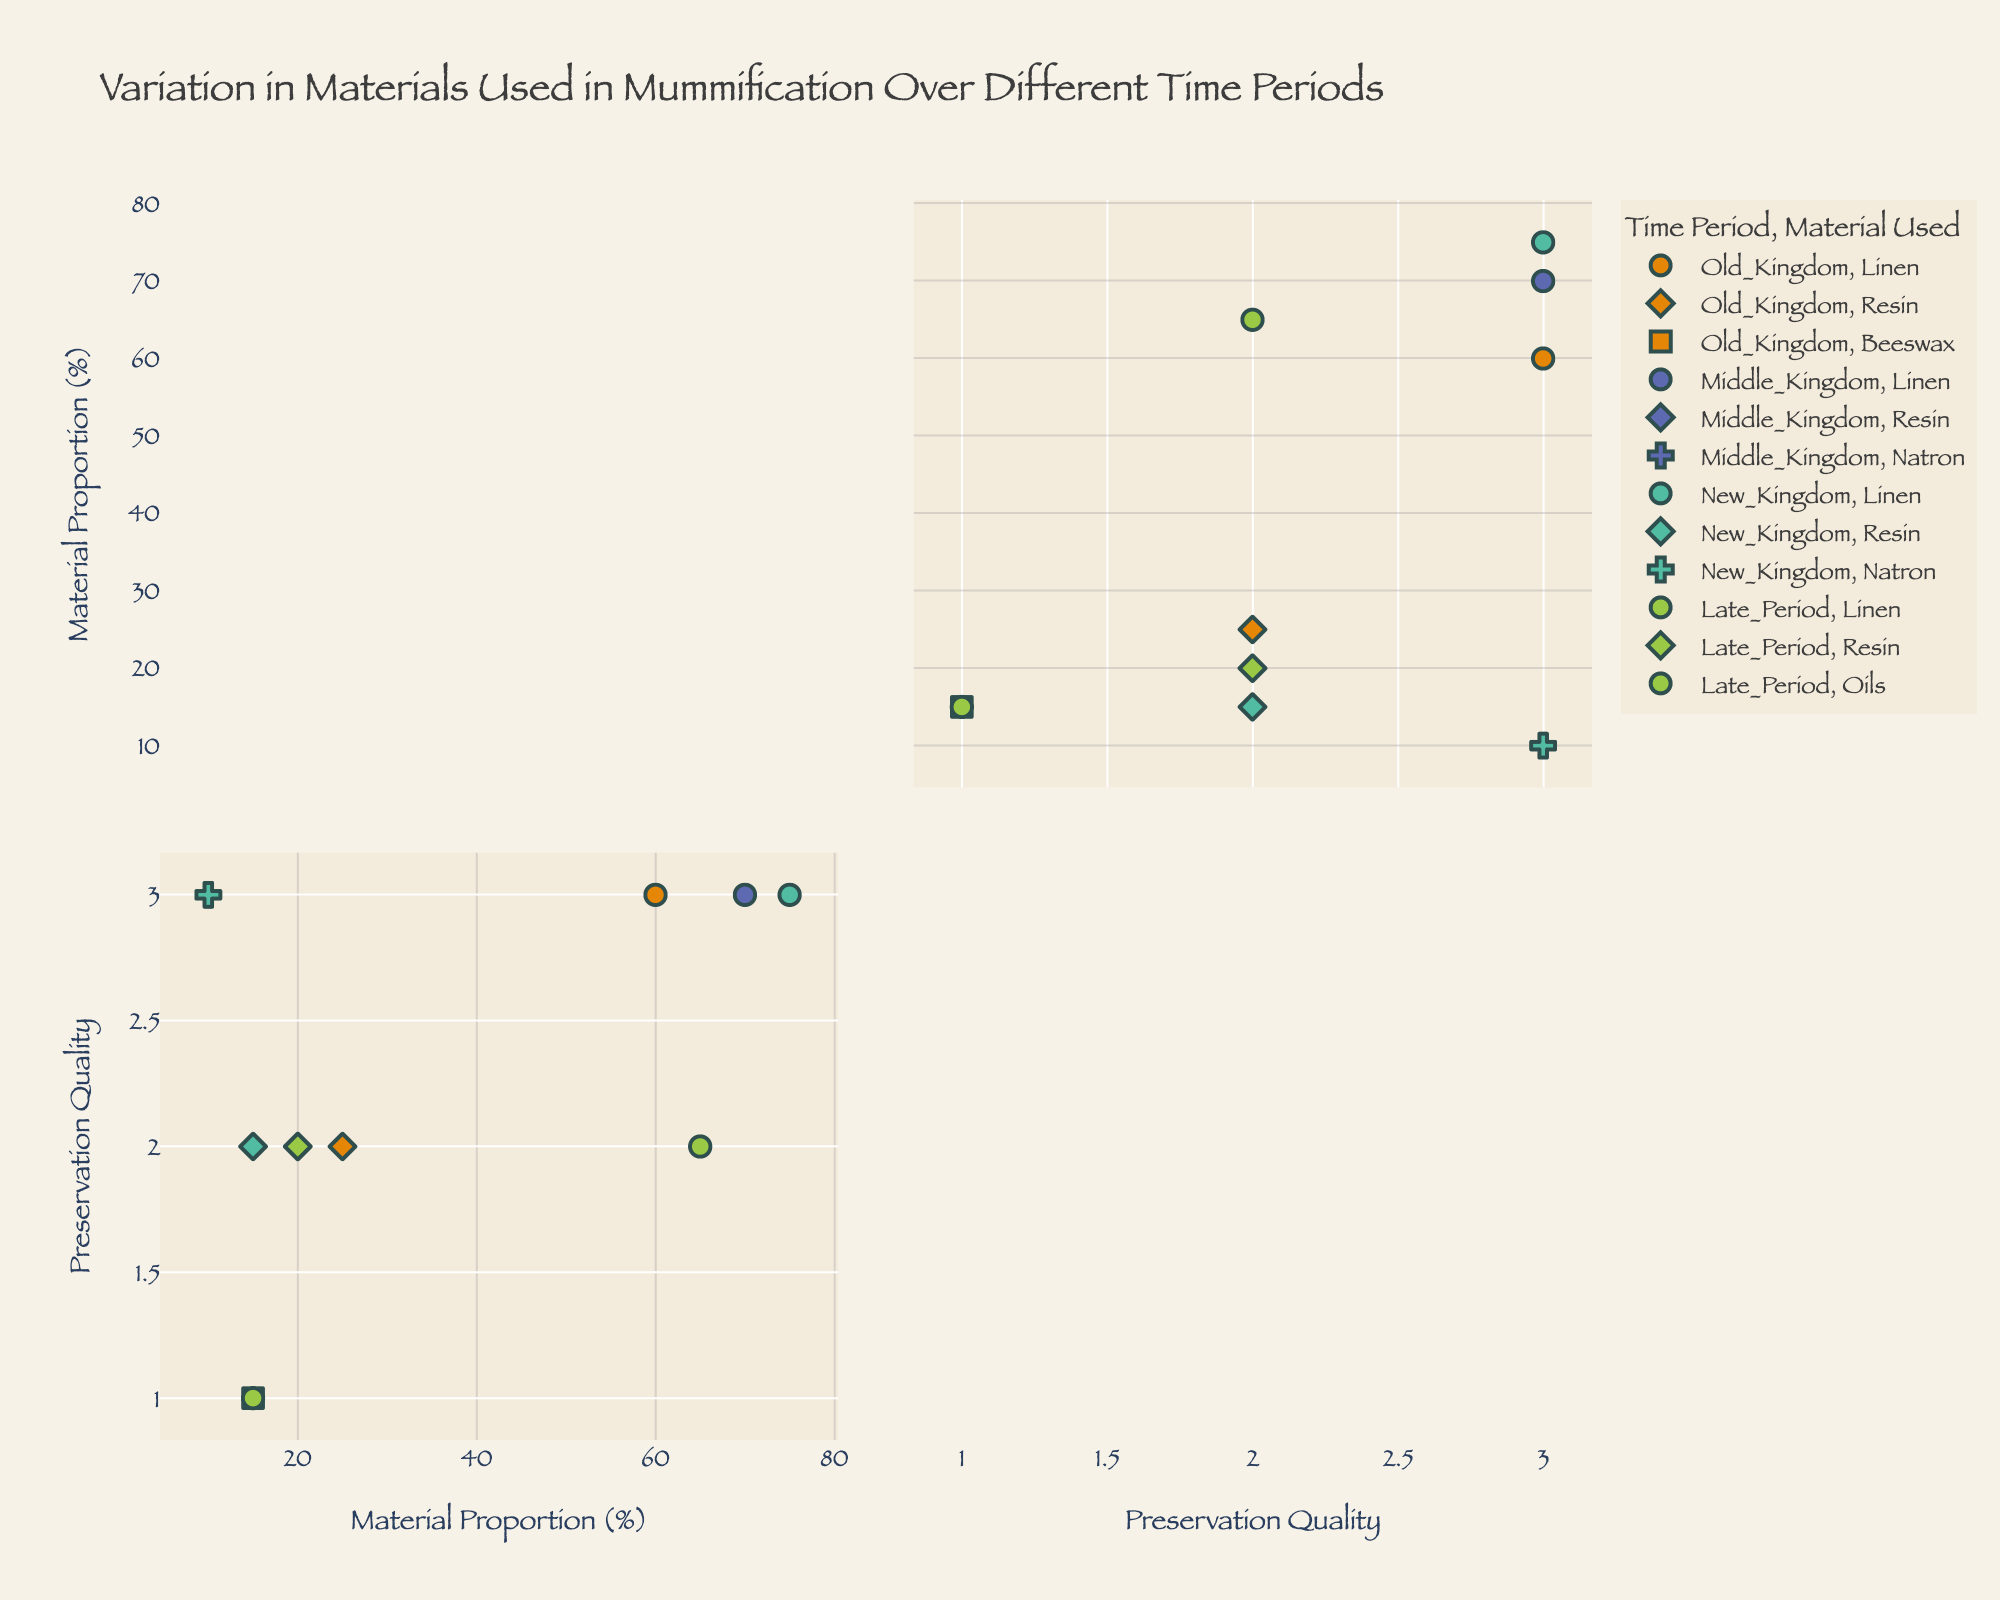What does the title of the figure indicate about its content? The title of the figure is "Variation in Materials Used in Mummification Over Different Time Periods," which suggests that the figure will display how different materials were used in varying proportions across different time periods in mummification practices.
Answer: Variation in Materials Used in Mummification Over Different Time Periods How many time periods are represented in the scatter plot matrix? By observing the colors or legends used to denote time periods, you can identify that four time periods are represented: Old Kingdom, Middle Kingdom, New Kingdom, and Late Period.
Answer: Four Which time period has the highest proportion of linen used in mummification? By looking at the plot, identify the time period with the highest value on the 'Material Proportion (%)' axis for linen. The New Kingdom has the highest proportion of linen at 75%.
Answer: New Kingdom How does the preservation quality of natron differ between the Middle Kingdom and New Kingdom? Locate the data points for natron in both the Middle Kingdom and New Kingdom by checking the symbol used for natron. Both periods have a preservation quality of 'Excellent,' mapped to the same marker indicating a value of 3 on the 'Preservation Quality' axis.
Answer: It is the same (Excellent) Compare the proportion of resin used between the Old Kingdom and Late Period. Identify the data points for resin in both the Old Kingdom (proportion 25%) and Late Period (proportion 20%) and compare their values on the 'Material Proportion (%)' axis.
Answer: Old Kingdom has a higher proportion of resin (25%) than Late Period (20%) What material has the highest proportion overall? Look for the data points with the highest 'Material Proportion (%)' value across all materials. Linen in the New Kingdom has the highest proportion at 75%.
Answer: Linen in the New Kingdom Can you identify a trend in the preservation quality of linen across different periods? Examine the preservation quality values of linen points across the periods. Linen in the Old Kingdom and Middle Kingdom has 'Excellent' quality, New Kingdom 'Excellent,' and Late Period 'Good.' The trend indicates a slight decline in preservation quality from 'Excellent' to 'Good' over time.
Answer: Decline from 'Excellent' to 'Good' What discovery site is associated with the highest proportion of beeswax? Check the 'Material' legend for beeswax and then find the data point with the highest proportion. Giza in the Old Kingdom has the highest and only recorded proportion of beeswax at 15%.
Answer: Giza Which material has the lowest proportion in all periods, and what is its preservation quality? Identify the material with the lowest 'Material Proportion (%)' values across the time periods. Natron in both Middle and New Kingdoms has the lowest proportion at 10%, with Excellent preservation quality for both.
Answer: Natron, Excellent 